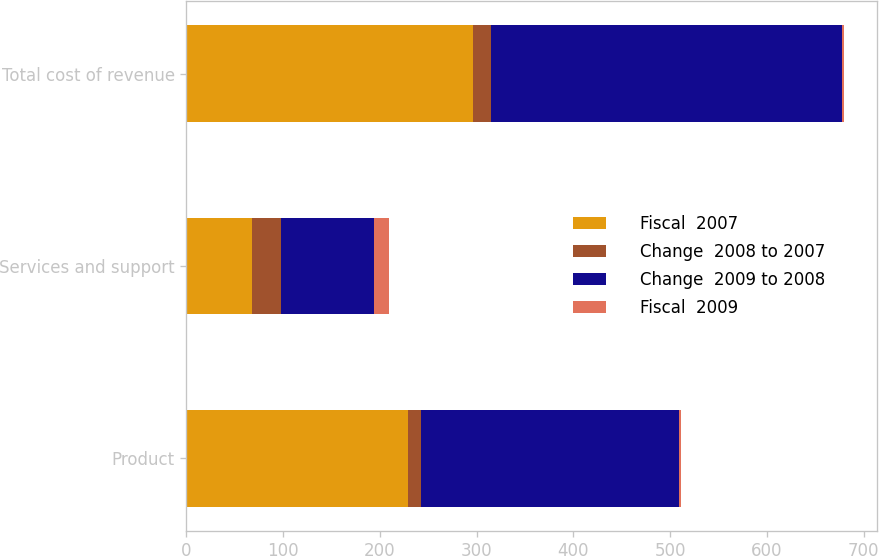<chart> <loc_0><loc_0><loc_500><loc_500><stacked_bar_chart><ecel><fcel>Product<fcel>Services and support<fcel>Total cost of revenue<nl><fcel>Fiscal  2007<fcel>228.9<fcel>67.8<fcel>296.7<nl><fcel>Change  2008 to 2007<fcel>14<fcel>30<fcel>18<nl><fcel>Change  2009 to 2008<fcel>266.4<fcel>96.2<fcel>362.6<nl><fcel>Fiscal  2009<fcel>2<fcel>15<fcel>2<nl></chart> 